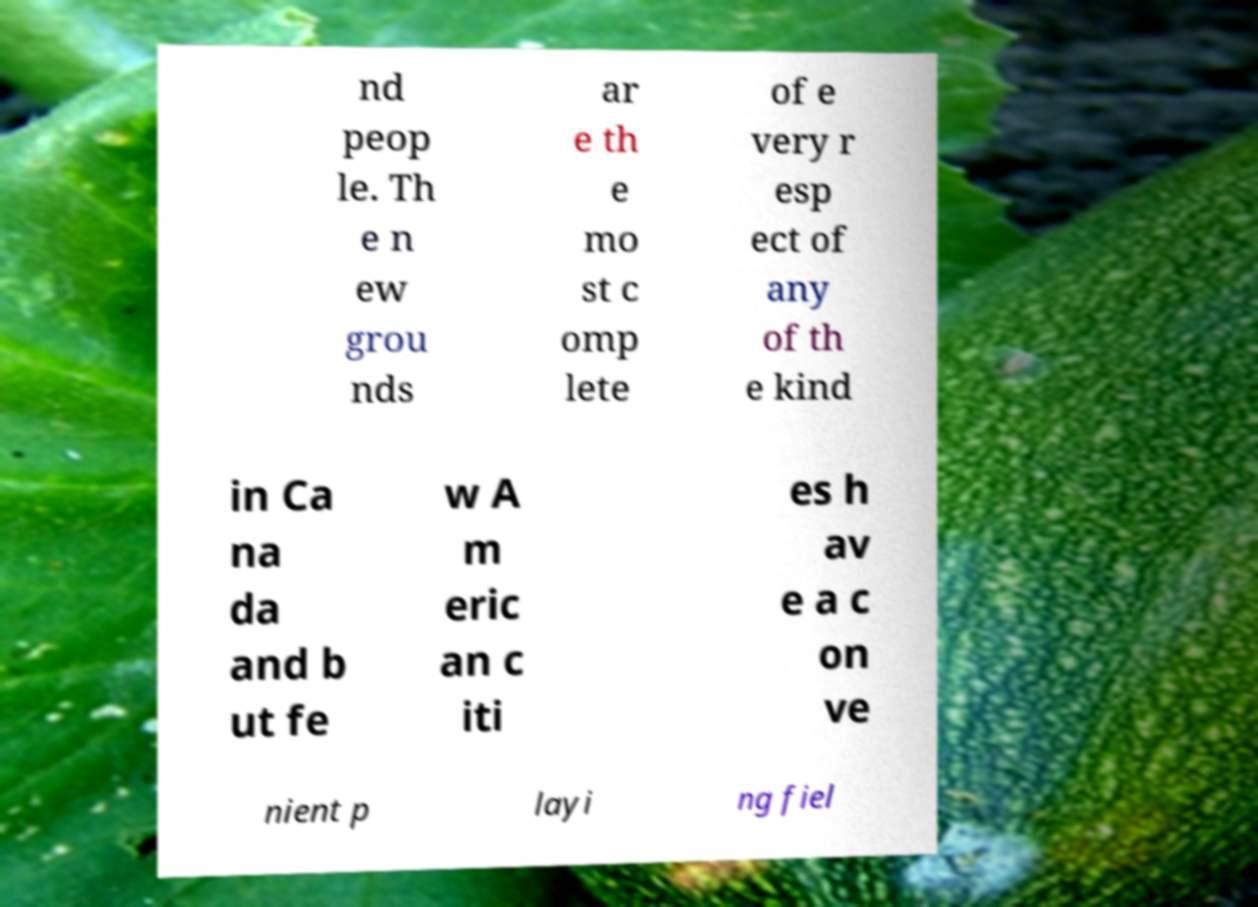There's text embedded in this image that I need extracted. Can you transcribe it verbatim? nd peop le. Th e n ew grou nds ar e th e mo st c omp lete of e very r esp ect of any of th e kind in Ca na da and b ut fe w A m eric an c iti es h av e a c on ve nient p layi ng fiel 